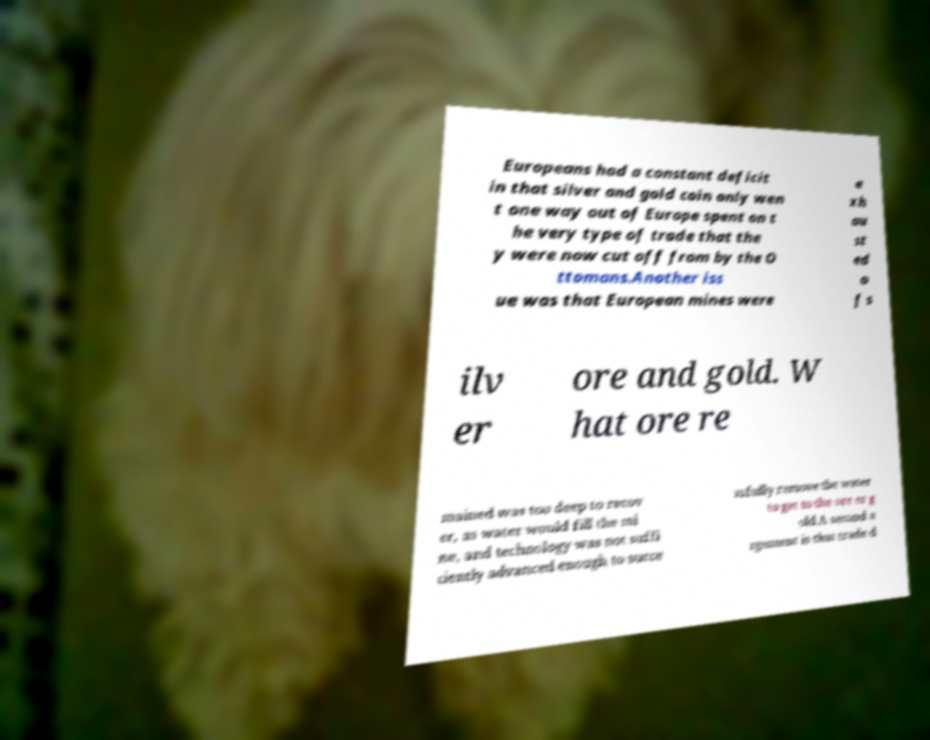There's text embedded in this image that I need extracted. Can you transcribe it verbatim? Europeans had a constant deficit in that silver and gold coin only wen t one way out of Europe spent on t he very type of trade that the y were now cut off from by the O ttomans.Another iss ue was that European mines were e xh au st ed o f s ilv er ore and gold. W hat ore re mained was too deep to recov er, as water would fill the mi ne, and technology was not suffi ciently advanced enough to succe ssfully remove the water to get to the ore or g old.A second a rgument is that trade d 